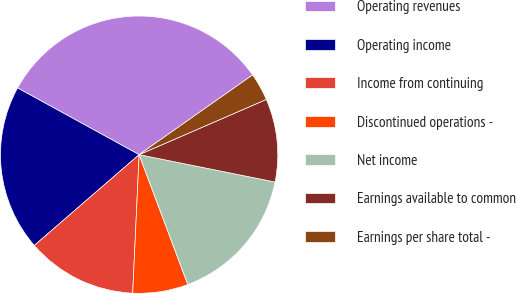<chart> <loc_0><loc_0><loc_500><loc_500><pie_chart><fcel>Operating revenues<fcel>Operating income<fcel>Income from continuing<fcel>Discontinued operations -<fcel>Net income<fcel>Earnings available to common<fcel>Earnings per share total -<nl><fcel>32.26%<fcel>19.35%<fcel>12.9%<fcel>6.45%<fcel>16.13%<fcel>9.68%<fcel>3.23%<nl></chart> 